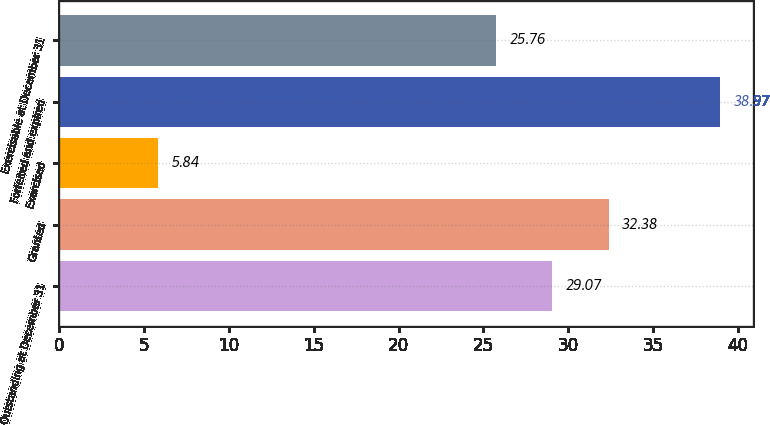Convert chart to OTSL. <chart><loc_0><loc_0><loc_500><loc_500><bar_chart><fcel>Outstanding at December 31<fcel>Granted<fcel>Exercised<fcel>Forfeited and expired<fcel>Exercisable at December 31<nl><fcel>29.07<fcel>32.38<fcel>5.84<fcel>38.97<fcel>25.76<nl></chart> 